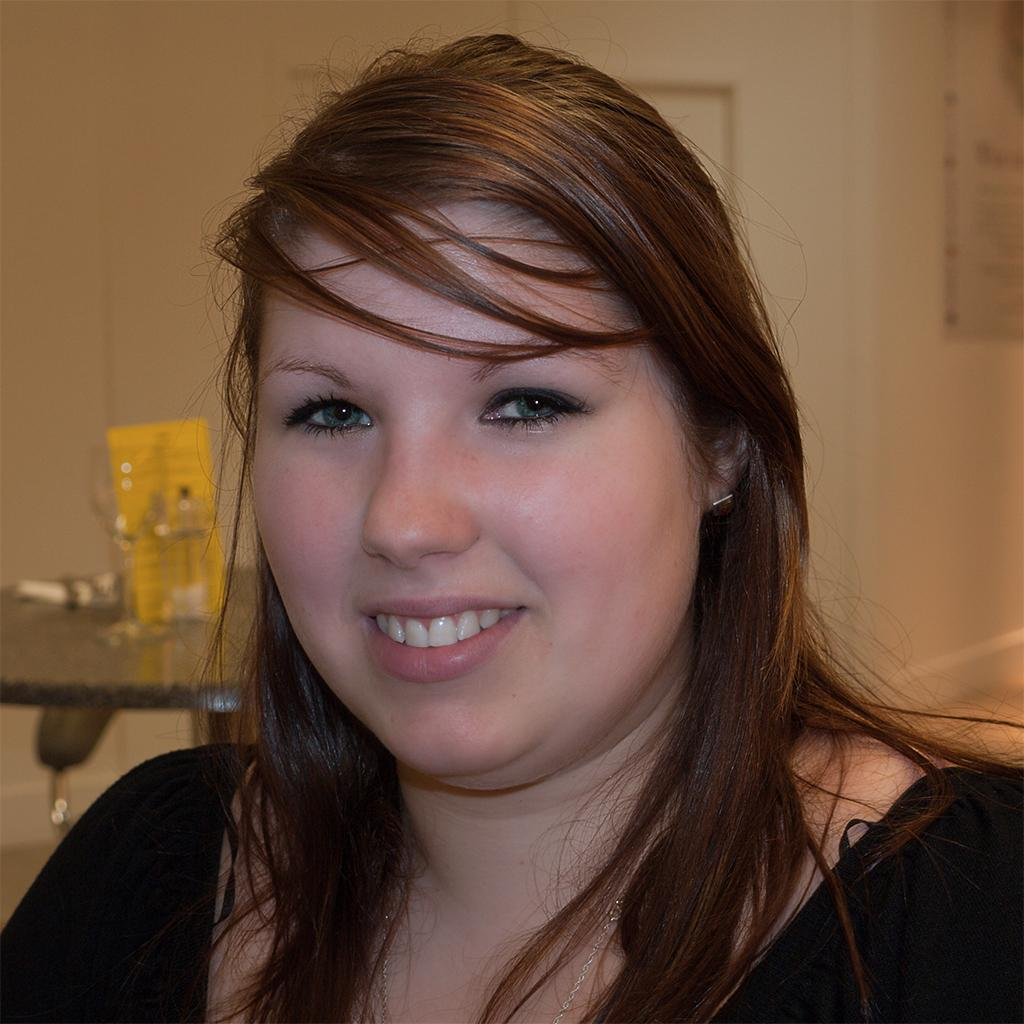Who is present in the image? There is a woman in the image. What is the woman wearing? The woman is wearing a black dress. What is the woman's facial expression? The woman is smiling. What can be seen in the background of the image? There is a table with objects on it, a cream-colored wall, and a door visible in the background. What type of juice is being served in the image? There is no juice present in the image. What part of the woman's body is made of flesh in the image? The image does not depict any exposed flesh or body parts; it only shows the woman's face and upper body, which are covered by her black dress. 